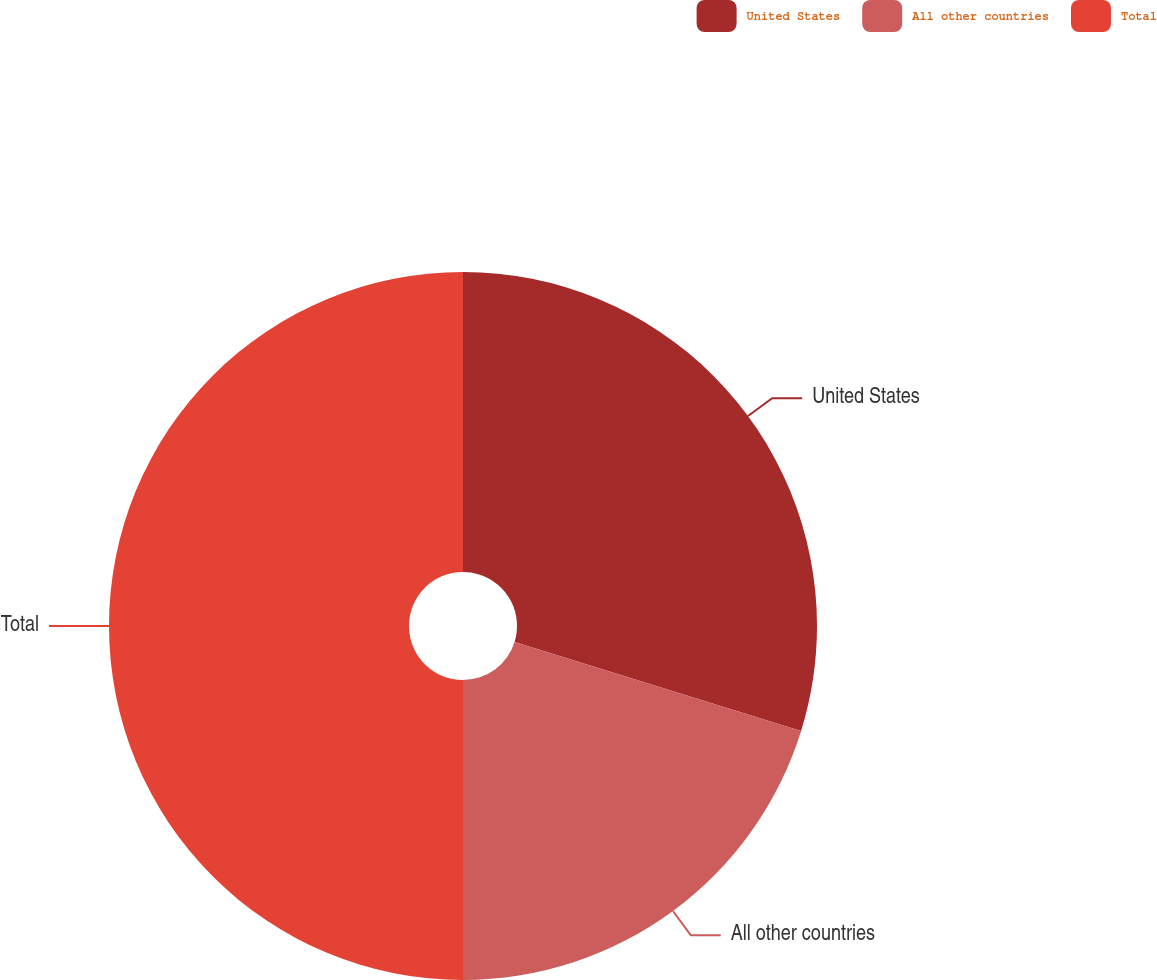Convert chart. <chart><loc_0><loc_0><loc_500><loc_500><pie_chart><fcel>United States<fcel>All other countries<fcel>Total<nl><fcel>29.79%<fcel>20.21%<fcel>50.0%<nl></chart> 